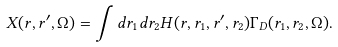<formula> <loc_0><loc_0><loc_500><loc_500>X ( r , r ^ { \prime } , \Omega ) = \int d r _ { 1 } d r _ { 2 } H ( r , r _ { 1 } , r ^ { \prime } , r _ { 2 } ) \Gamma _ { D } ( r _ { 1 } , r _ { 2 } , \Omega ) .</formula> 